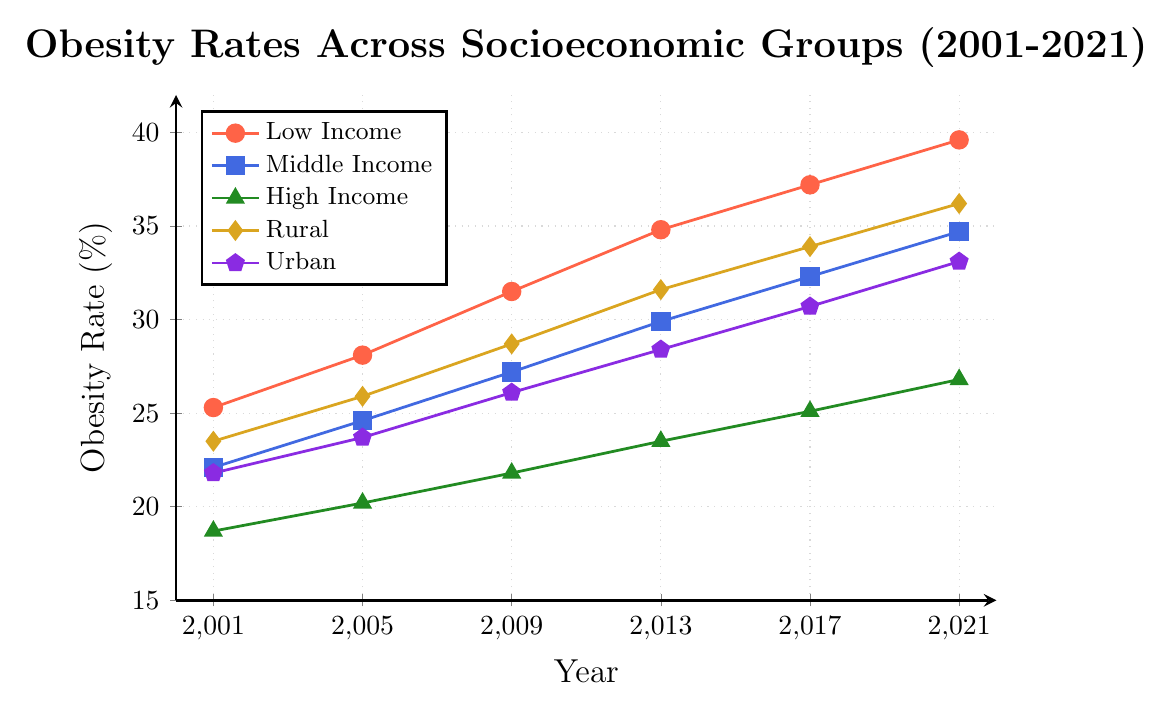Which socioeconomic group had the highest obesity rate in 2021? Based on the plot, the Low Income group had the highest obesity rate in 2021, at approximately 39.6%. This can be identified by looking at the highest point among all the groups on the right end of the plot.
Answer: Low Income How much did the obesity rate increase in the Middle Income group from 2001 to 2021? In 2001, the obesity rate for Middle Income was 22.1%, and in 2021, it was 34.7%. The increase can be calculated as 34.7% - 22.1% = 12.6%.
Answer: 12.6% Which group showed the smallest overall increase in obesity rates from 2001 to 2021? The High Income group had the smallest increase. In 2001, the rate was 18.7%, and in 2021, it was 26.8%, resulting in an increase of 26.8% - 18.7% = 8.1%. By comparing this difference with other groups, one can see it is the smallest.
Answer: High Income In which year did the Urban group's obesity rate surpass the 30% mark? Looking at the Urban group's plot line, it shows that the rate first surpassed 30% in the year 2017, reaching approximately 30.7%.
Answer: 2017 Compare the obesity rates between Rural and Urban groups in 2021. Which was higher, and by how much? In 2021, the Rural group had an obesity rate of 36.2%, and the Urban group had a rate of 33.1%. The difference is 36.2% - 33.1% = 3.1%, with the Rural group having the higher rate.
Answer: Rural, by 3.1% Which socioeconomic group had the largest percentage increase in obesity rates from 2001 to 2021? To find the largest percentage increase, calculate the percentage increase for each group: 
Low Income: ((39.6 - 25.3) / 25.3) * 100 ≈ 56.5%
Middle Income: ((34.7 - 22.1) / 22.1) * 100 ≈ 57.0%
High Income: ((26.8 - 18.7) / 18.7) * 100 ≈ 43.3%
Rural: ((36.2 - 23.5) / 23.5) * 100 ≈ 54.0%
Urban: ((33.1 - 21.8) / 21.8) * 100 ≈ 52.3%
The Middle Income group had the largest percentage increase at approximately 57%.
Answer: Middle Income What is the average obesity rate for the High Income group over the 20 years? Sum the values for High Income: 18.7 + 20.2 + 21.8 + 23.5 + 25.1 + 26.8 = 136.1. There are 6 data points, so the average is 136.1 / 6 ≈ 22.68%.
Answer: 22.68% In which year did the Low Income and Rural groups have the closest obesity rates, and what was the difference? Checking each year from the plot:
2001: 25.3% (Low) vs. 23.5% (Rural), Difference = 1.8%
2005: 28.1% (Low) vs. 25.9% (Rural), Difference = 2.2%
2009: 31.5% (Low) vs. 28.7% (Rural), Difference = 2.8%
2013: 34.8% (Low) vs. 31.6% (Rural), Difference = 3.2%
2017: 37.2% (Low) vs. 33.9% (Rural), Difference = 3.3%
2021: 39.6% (Low) vs. 36.2% (Rural), Difference = 3.4%
The closest was in 2001 with a difference of 1.8%.
Answer: 2001, Difference: 1.8% 